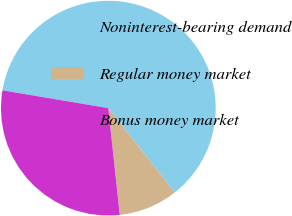<chart> <loc_0><loc_0><loc_500><loc_500><pie_chart><fcel>Noninterest-bearing demand<fcel>Regular money market<fcel>Bonus money market<nl><fcel>61.71%<fcel>8.94%<fcel>29.35%<nl></chart> 